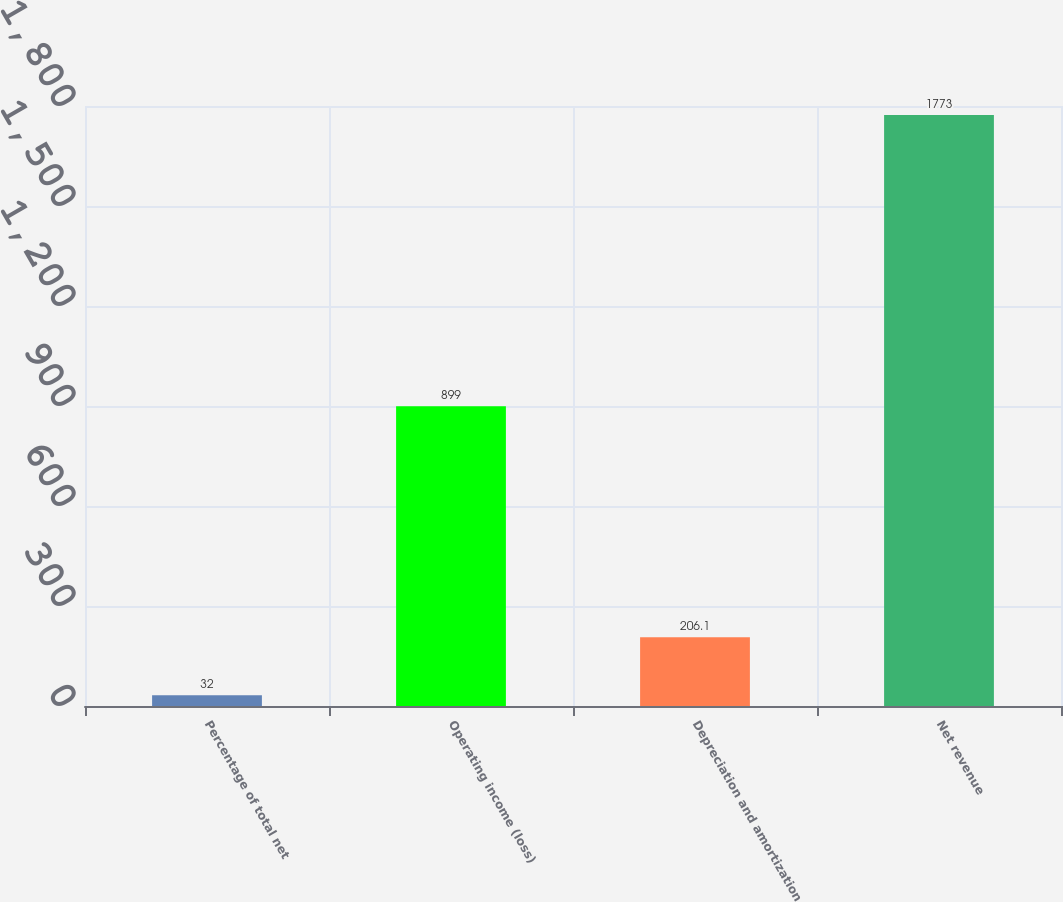Convert chart to OTSL. <chart><loc_0><loc_0><loc_500><loc_500><bar_chart><fcel>Percentage of total net<fcel>Operating income (loss)<fcel>Depreciation and amortization<fcel>Net revenue<nl><fcel>32<fcel>899<fcel>206.1<fcel>1773<nl></chart> 